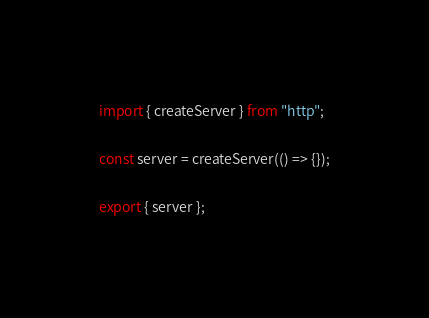Convert code to text. <code><loc_0><loc_0><loc_500><loc_500><_TypeScript_>import { createServer } from "http";

const server = createServer(() => {});

export { server };
</code> 